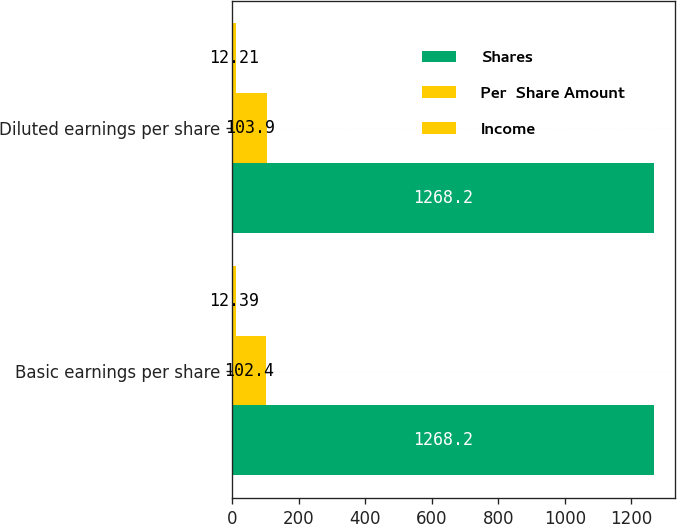Convert chart. <chart><loc_0><loc_0><loc_500><loc_500><stacked_bar_chart><ecel><fcel>Basic earnings per share<fcel>Diluted earnings per share<nl><fcel>Shares<fcel>1268.2<fcel>1268.2<nl><fcel>Per  Share Amount<fcel>102.4<fcel>103.9<nl><fcel>Income<fcel>12.39<fcel>12.21<nl></chart> 